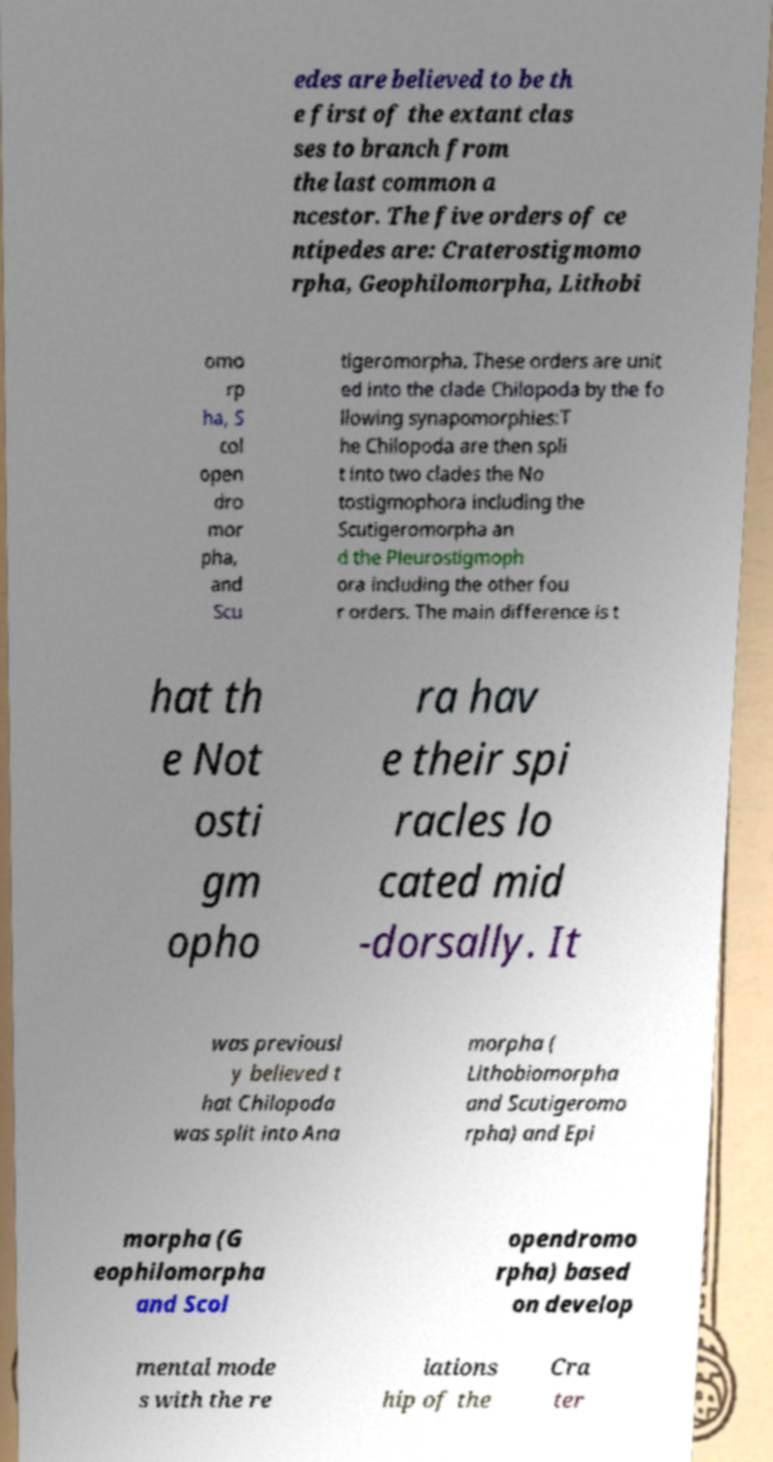What messages or text are displayed in this image? I need them in a readable, typed format. edes are believed to be th e first of the extant clas ses to branch from the last common a ncestor. The five orders of ce ntipedes are: Craterostigmomo rpha, Geophilomorpha, Lithobi omo rp ha, S col open dro mor pha, and Scu tigeromorpha. These orders are unit ed into the clade Chilopoda by the fo llowing synapomorphies:T he Chilopoda are then spli t into two clades the No tostigmophora including the Scutigeromorpha an d the Pleurostigmoph ora including the other fou r orders. The main difference is t hat th e Not osti gm opho ra hav e their spi racles lo cated mid -dorsally. It was previousl y believed t hat Chilopoda was split into Ana morpha ( Lithobiomorpha and Scutigeromo rpha) and Epi morpha (G eophilomorpha and Scol opendromo rpha) based on develop mental mode s with the re lations hip of the Cra ter 